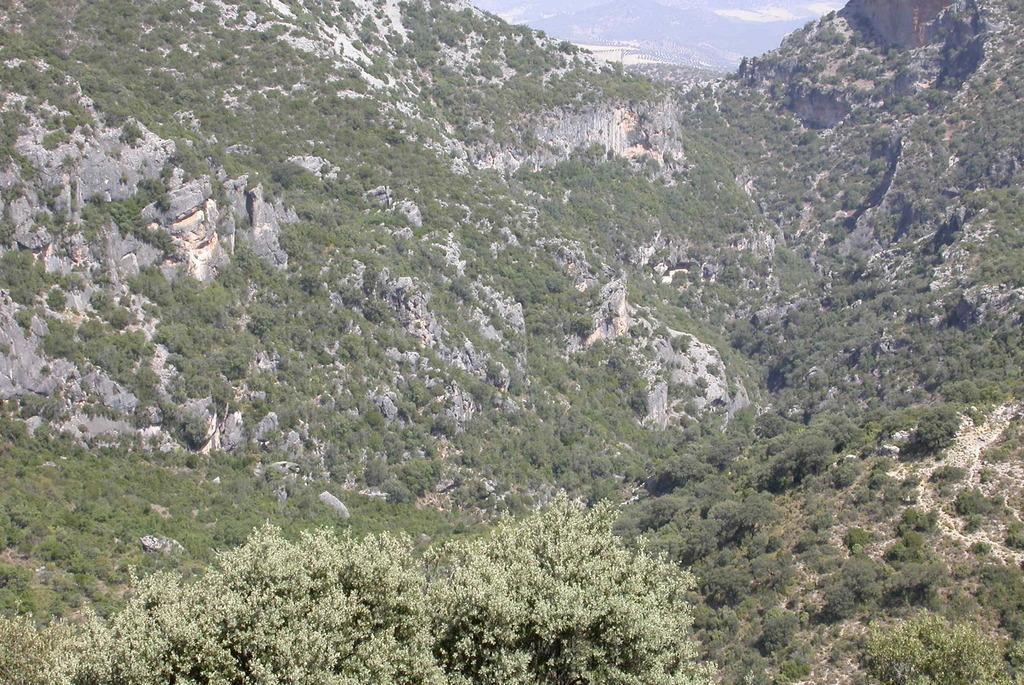Describe this image in one or two sentences. In this image I can see trees and mountains which are in green color. 